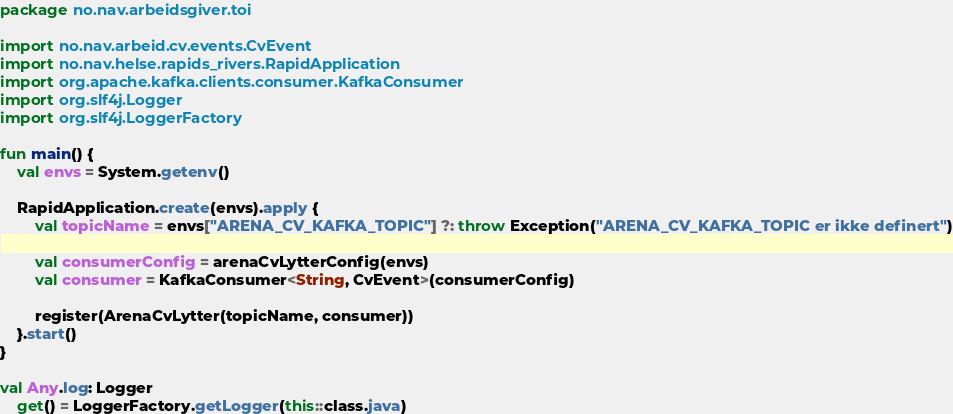Convert code to text. <code><loc_0><loc_0><loc_500><loc_500><_Kotlin_>package no.nav.arbeidsgiver.toi

import no.nav.arbeid.cv.events.CvEvent
import no.nav.helse.rapids_rivers.RapidApplication
import org.apache.kafka.clients.consumer.KafkaConsumer
import org.slf4j.Logger
import org.slf4j.LoggerFactory

fun main() {
    val envs = System.getenv()

    RapidApplication.create(envs).apply {
        val topicName = envs["ARENA_CV_KAFKA_TOPIC"] ?: throw Exception("ARENA_CV_KAFKA_TOPIC er ikke definert")

        val consumerConfig = arenaCvLytterConfig(envs)
        val consumer = KafkaConsumer<String, CvEvent>(consumerConfig)

        register(ArenaCvLytter(topicName, consumer))
    }.start()
}

val Any.log: Logger
    get() = LoggerFactory.getLogger(this::class.java)
</code> 